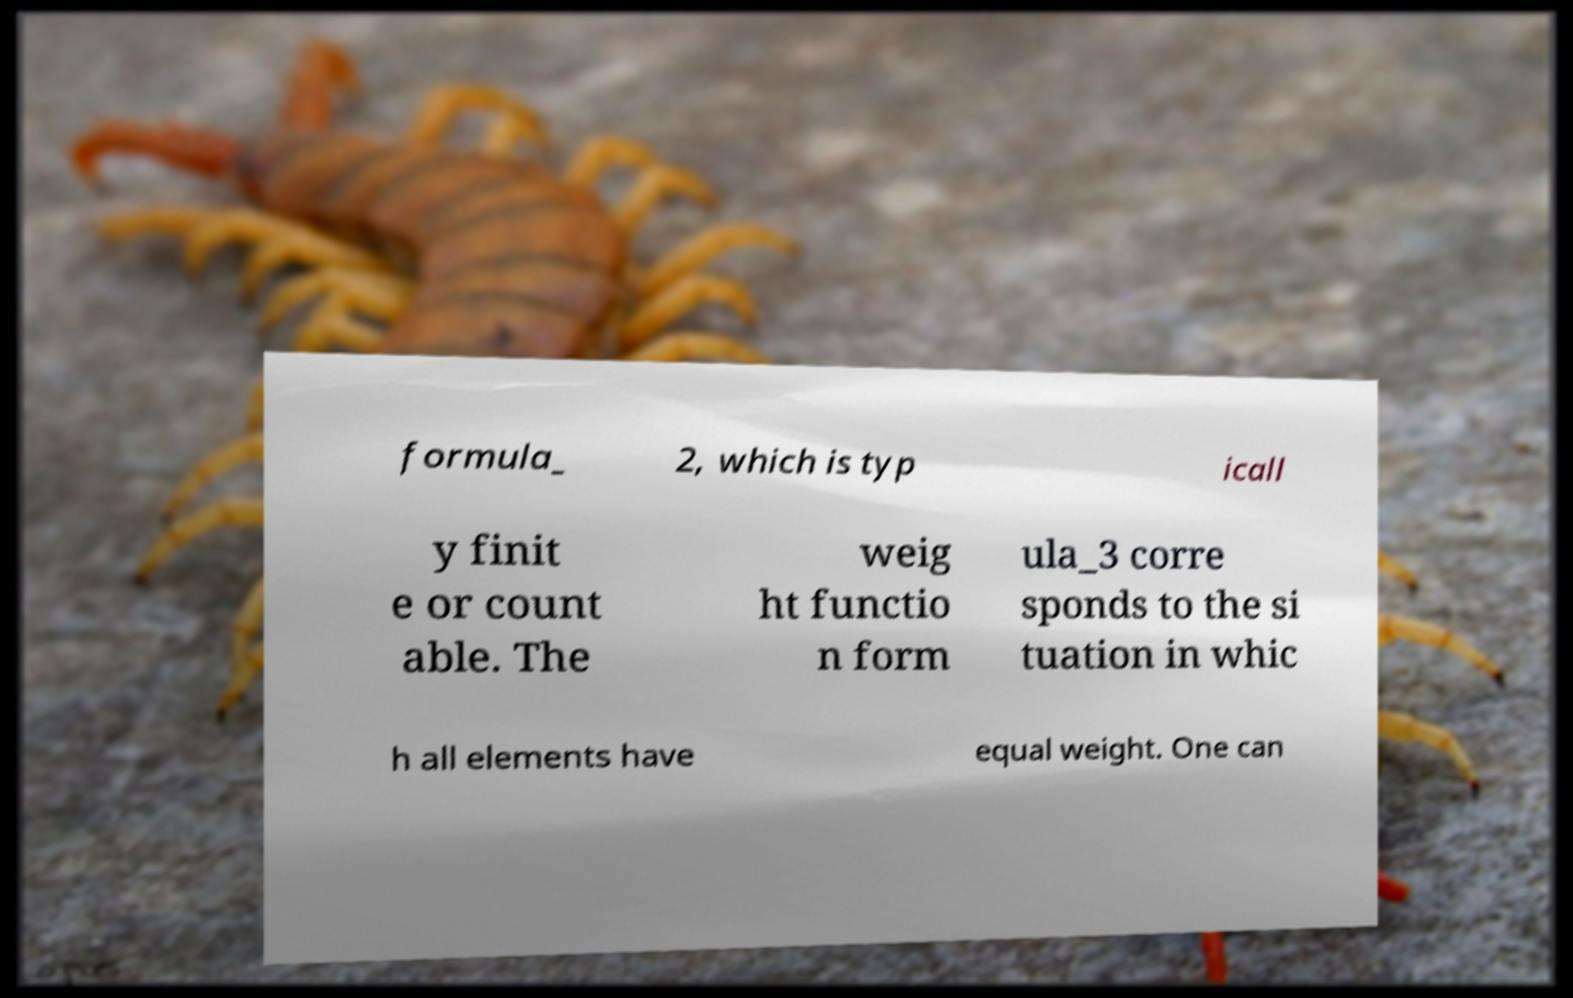Can you accurately transcribe the text from the provided image for me? formula_ 2, which is typ icall y finit e or count able. The weig ht functio n form ula_3 corre sponds to the si tuation in whic h all elements have equal weight. One can 